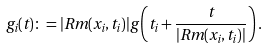<formula> <loc_0><loc_0><loc_500><loc_500>g _ { i } ( t ) \colon = | R m ( x _ { i } , t _ { i } ) | g \left ( t _ { i } + \frac { t } { | R m ( x _ { i } , t _ { i } ) | } \right ) .</formula> 